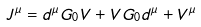<formula> <loc_0><loc_0><loc_500><loc_500>J ^ { \mu } = d ^ { \mu } G _ { 0 } V + V G _ { 0 } d ^ { \mu } + V ^ { \mu }</formula> 